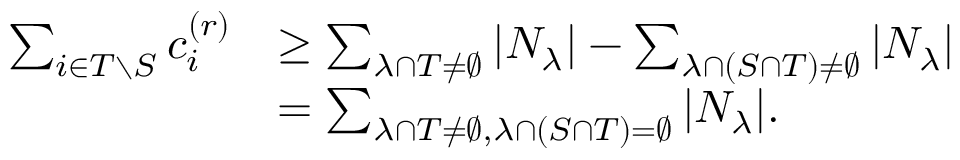<formula> <loc_0><loc_0><loc_500><loc_500>\begin{array} { r l } { \sum _ { i \in T \ S } c _ { i } ^ { ( r ) } } & { \geq \sum _ { \lambda \cap T \neq \emptyset } | N _ { \lambda } | - \sum _ { \lambda \cap ( S \cap T ) \neq \emptyset } | N _ { \lambda } | } \\ & { = \sum _ { \lambda \cap T \neq \emptyset , \lambda \cap ( S \cap T ) = \emptyset } | N _ { \lambda } | . } \end{array}</formula> 